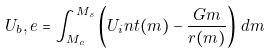<formula> <loc_0><loc_0><loc_500><loc_500>U _ { b } , e = \int _ { M _ { c } } ^ { M _ { s } } \left ( U _ { i } n t ( m ) - \frac { G m } { r ( m ) } \right ) \, d m</formula> 